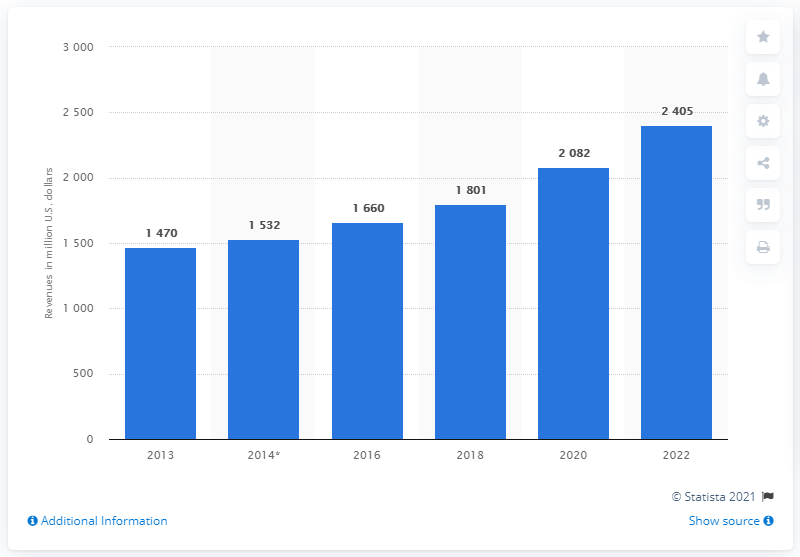Mention a couple of crucial points in this snapshot. In 2013, the revenue generated by carbon composite products was approximately 1470. The global revenue in the sport and leisure market from carbon composite was in the year 2013. 